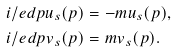Convert formula to latex. <formula><loc_0><loc_0><loc_500><loc_500>i \slash e d { p } u _ { s } ( p ) & = - m u _ { s } ( p ) , \\ i \slash e d { p } v _ { s } ( p ) & = m v _ { s } ( p ) .</formula> 